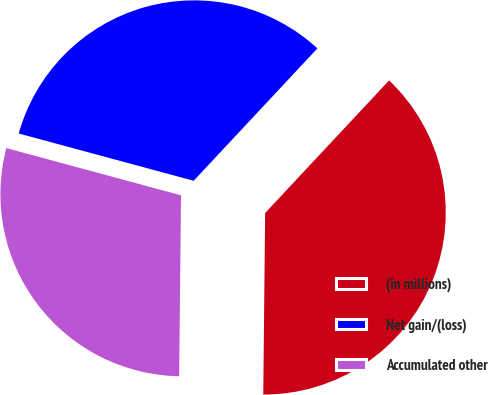Convert chart to OTSL. <chart><loc_0><loc_0><loc_500><loc_500><pie_chart><fcel>(in millions)<fcel>Net gain/(loss)<fcel>Accumulated other<nl><fcel>38.2%<fcel>32.76%<fcel>29.04%<nl></chart> 